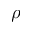<formula> <loc_0><loc_0><loc_500><loc_500>\rho</formula> 